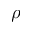<formula> <loc_0><loc_0><loc_500><loc_500>\rho</formula> 